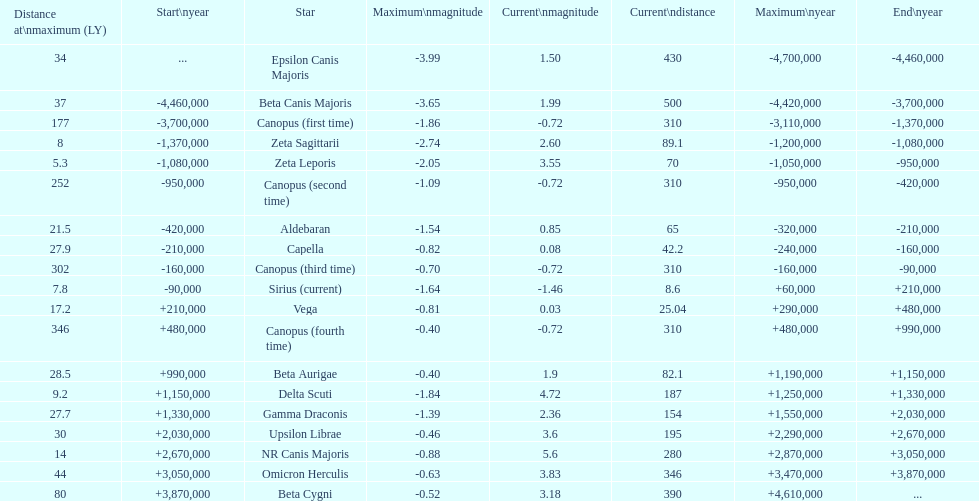Which star has the highest distance at maximum? Canopus (fourth time). 